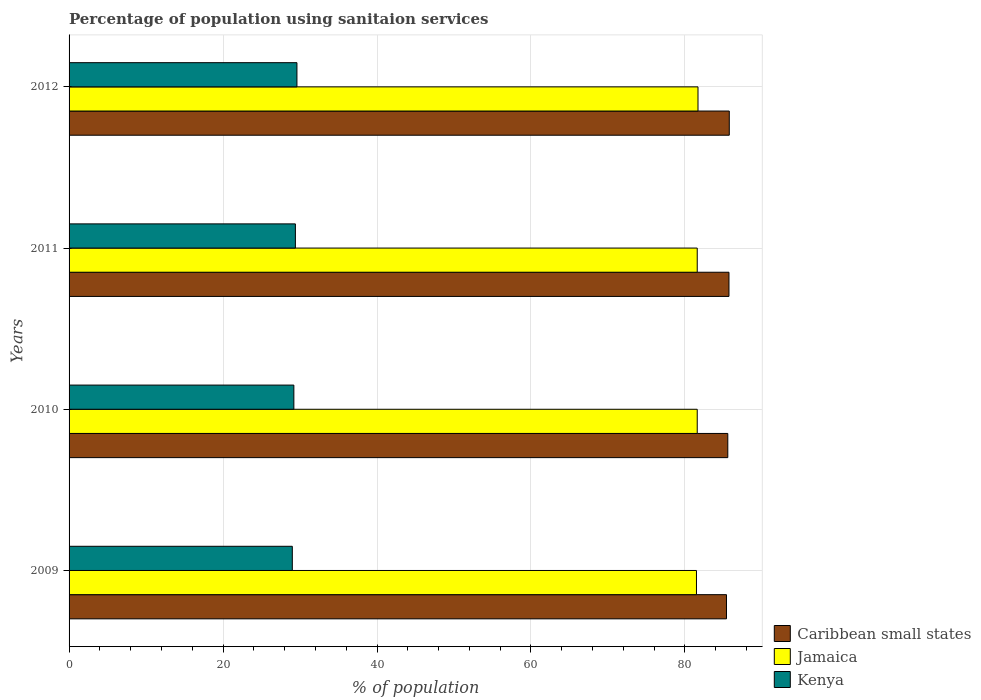How many different coloured bars are there?
Give a very brief answer. 3. Are the number of bars on each tick of the Y-axis equal?
Your answer should be compact. Yes. How many bars are there on the 3rd tick from the top?
Give a very brief answer. 3. What is the percentage of population using sanitaion services in Jamaica in 2009?
Offer a terse response. 81.5. Across all years, what is the maximum percentage of population using sanitaion services in Jamaica?
Your answer should be compact. 81.7. Across all years, what is the minimum percentage of population using sanitaion services in Jamaica?
Keep it short and to the point. 81.5. In which year was the percentage of population using sanitaion services in Caribbean small states maximum?
Your answer should be compact. 2012. In which year was the percentage of population using sanitaion services in Jamaica minimum?
Offer a terse response. 2009. What is the total percentage of population using sanitaion services in Kenya in the graph?
Give a very brief answer. 117.2. What is the difference between the percentage of population using sanitaion services in Kenya in 2009 and that in 2010?
Your response must be concise. -0.2. What is the difference between the percentage of population using sanitaion services in Caribbean small states in 2009 and the percentage of population using sanitaion services in Jamaica in 2012?
Offer a very short reply. 3.7. What is the average percentage of population using sanitaion services in Jamaica per year?
Provide a short and direct response. 81.6. In the year 2010, what is the difference between the percentage of population using sanitaion services in Caribbean small states and percentage of population using sanitaion services in Jamaica?
Provide a short and direct response. 3.97. What is the ratio of the percentage of population using sanitaion services in Jamaica in 2009 to that in 2010?
Your response must be concise. 1. Is the percentage of population using sanitaion services in Caribbean small states in 2009 less than that in 2011?
Ensure brevity in your answer.  Yes. Is the difference between the percentage of population using sanitaion services in Caribbean small states in 2009 and 2012 greater than the difference between the percentage of population using sanitaion services in Jamaica in 2009 and 2012?
Provide a short and direct response. No. What is the difference between the highest and the second highest percentage of population using sanitaion services in Jamaica?
Provide a short and direct response. 0.1. What is the difference between the highest and the lowest percentage of population using sanitaion services in Caribbean small states?
Make the answer very short. 0.36. Is the sum of the percentage of population using sanitaion services in Caribbean small states in 2009 and 2010 greater than the maximum percentage of population using sanitaion services in Jamaica across all years?
Your answer should be very brief. Yes. What does the 1st bar from the top in 2010 represents?
Your response must be concise. Kenya. What does the 2nd bar from the bottom in 2009 represents?
Provide a succinct answer. Jamaica. Is it the case that in every year, the sum of the percentage of population using sanitaion services in Caribbean small states and percentage of population using sanitaion services in Kenya is greater than the percentage of population using sanitaion services in Jamaica?
Your answer should be compact. Yes. Are all the bars in the graph horizontal?
Offer a very short reply. Yes. What is the difference between two consecutive major ticks on the X-axis?
Offer a very short reply. 20. Does the graph contain any zero values?
Keep it short and to the point. No. Where does the legend appear in the graph?
Your response must be concise. Bottom right. How many legend labels are there?
Keep it short and to the point. 3. How are the legend labels stacked?
Offer a terse response. Vertical. What is the title of the graph?
Provide a short and direct response. Percentage of population using sanitaion services. What is the label or title of the X-axis?
Provide a succinct answer. % of population. What is the % of population of Caribbean small states in 2009?
Offer a very short reply. 85.4. What is the % of population in Jamaica in 2009?
Offer a terse response. 81.5. What is the % of population of Kenya in 2009?
Provide a short and direct response. 29. What is the % of population in Caribbean small states in 2010?
Ensure brevity in your answer.  85.57. What is the % of population in Jamaica in 2010?
Keep it short and to the point. 81.6. What is the % of population of Kenya in 2010?
Provide a succinct answer. 29.2. What is the % of population of Caribbean small states in 2011?
Ensure brevity in your answer.  85.72. What is the % of population in Jamaica in 2011?
Provide a succinct answer. 81.6. What is the % of population of Kenya in 2011?
Make the answer very short. 29.4. What is the % of population in Caribbean small states in 2012?
Your answer should be very brief. 85.76. What is the % of population of Jamaica in 2012?
Your answer should be compact. 81.7. What is the % of population of Kenya in 2012?
Provide a succinct answer. 29.6. Across all years, what is the maximum % of population in Caribbean small states?
Give a very brief answer. 85.76. Across all years, what is the maximum % of population in Jamaica?
Offer a very short reply. 81.7. Across all years, what is the maximum % of population of Kenya?
Your response must be concise. 29.6. Across all years, what is the minimum % of population in Caribbean small states?
Provide a short and direct response. 85.4. Across all years, what is the minimum % of population of Jamaica?
Keep it short and to the point. 81.5. What is the total % of population of Caribbean small states in the graph?
Your response must be concise. 342.45. What is the total % of population in Jamaica in the graph?
Make the answer very short. 326.4. What is the total % of population of Kenya in the graph?
Give a very brief answer. 117.2. What is the difference between the % of population of Caribbean small states in 2009 and that in 2010?
Ensure brevity in your answer.  -0.17. What is the difference between the % of population of Kenya in 2009 and that in 2010?
Your answer should be compact. -0.2. What is the difference between the % of population in Caribbean small states in 2009 and that in 2011?
Your response must be concise. -0.32. What is the difference between the % of population of Jamaica in 2009 and that in 2011?
Give a very brief answer. -0.1. What is the difference between the % of population of Kenya in 2009 and that in 2011?
Offer a very short reply. -0.4. What is the difference between the % of population in Caribbean small states in 2009 and that in 2012?
Provide a succinct answer. -0.36. What is the difference between the % of population in Jamaica in 2009 and that in 2012?
Keep it short and to the point. -0.2. What is the difference between the % of population in Kenya in 2009 and that in 2012?
Offer a terse response. -0.6. What is the difference between the % of population in Caribbean small states in 2010 and that in 2011?
Keep it short and to the point. -0.15. What is the difference between the % of population of Caribbean small states in 2010 and that in 2012?
Your response must be concise. -0.19. What is the difference between the % of population in Kenya in 2010 and that in 2012?
Provide a succinct answer. -0.4. What is the difference between the % of population of Caribbean small states in 2011 and that in 2012?
Provide a short and direct response. -0.04. What is the difference between the % of population in Jamaica in 2011 and that in 2012?
Keep it short and to the point. -0.1. What is the difference between the % of population of Kenya in 2011 and that in 2012?
Give a very brief answer. -0.2. What is the difference between the % of population in Caribbean small states in 2009 and the % of population in Jamaica in 2010?
Your response must be concise. 3.8. What is the difference between the % of population in Caribbean small states in 2009 and the % of population in Kenya in 2010?
Your answer should be compact. 56.2. What is the difference between the % of population of Jamaica in 2009 and the % of population of Kenya in 2010?
Provide a short and direct response. 52.3. What is the difference between the % of population in Caribbean small states in 2009 and the % of population in Jamaica in 2011?
Give a very brief answer. 3.8. What is the difference between the % of population in Caribbean small states in 2009 and the % of population in Kenya in 2011?
Offer a terse response. 56. What is the difference between the % of population in Jamaica in 2009 and the % of population in Kenya in 2011?
Offer a very short reply. 52.1. What is the difference between the % of population of Caribbean small states in 2009 and the % of population of Jamaica in 2012?
Offer a very short reply. 3.7. What is the difference between the % of population of Caribbean small states in 2009 and the % of population of Kenya in 2012?
Give a very brief answer. 55.8. What is the difference between the % of population in Jamaica in 2009 and the % of population in Kenya in 2012?
Keep it short and to the point. 51.9. What is the difference between the % of population of Caribbean small states in 2010 and the % of population of Jamaica in 2011?
Provide a short and direct response. 3.97. What is the difference between the % of population in Caribbean small states in 2010 and the % of population in Kenya in 2011?
Your answer should be compact. 56.17. What is the difference between the % of population of Jamaica in 2010 and the % of population of Kenya in 2011?
Keep it short and to the point. 52.2. What is the difference between the % of population of Caribbean small states in 2010 and the % of population of Jamaica in 2012?
Your answer should be very brief. 3.87. What is the difference between the % of population in Caribbean small states in 2010 and the % of population in Kenya in 2012?
Provide a succinct answer. 55.97. What is the difference between the % of population of Jamaica in 2010 and the % of population of Kenya in 2012?
Your response must be concise. 52. What is the difference between the % of population of Caribbean small states in 2011 and the % of population of Jamaica in 2012?
Provide a succinct answer. 4.02. What is the difference between the % of population of Caribbean small states in 2011 and the % of population of Kenya in 2012?
Your response must be concise. 56.12. What is the difference between the % of population in Jamaica in 2011 and the % of population in Kenya in 2012?
Keep it short and to the point. 52. What is the average % of population of Caribbean small states per year?
Give a very brief answer. 85.61. What is the average % of population of Jamaica per year?
Provide a succinct answer. 81.6. What is the average % of population in Kenya per year?
Offer a terse response. 29.3. In the year 2009, what is the difference between the % of population of Caribbean small states and % of population of Jamaica?
Keep it short and to the point. 3.9. In the year 2009, what is the difference between the % of population of Caribbean small states and % of population of Kenya?
Offer a very short reply. 56.4. In the year 2009, what is the difference between the % of population in Jamaica and % of population in Kenya?
Your answer should be compact. 52.5. In the year 2010, what is the difference between the % of population in Caribbean small states and % of population in Jamaica?
Provide a short and direct response. 3.97. In the year 2010, what is the difference between the % of population of Caribbean small states and % of population of Kenya?
Offer a very short reply. 56.37. In the year 2010, what is the difference between the % of population in Jamaica and % of population in Kenya?
Your response must be concise. 52.4. In the year 2011, what is the difference between the % of population of Caribbean small states and % of population of Jamaica?
Give a very brief answer. 4.12. In the year 2011, what is the difference between the % of population of Caribbean small states and % of population of Kenya?
Ensure brevity in your answer.  56.32. In the year 2011, what is the difference between the % of population in Jamaica and % of population in Kenya?
Keep it short and to the point. 52.2. In the year 2012, what is the difference between the % of population of Caribbean small states and % of population of Jamaica?
Ensure brevity in your answer.  4.06. In the year 2012, what is the difference between the % of population of Caribbean small states and % of population of Kenya?
Your response must be concise. 56.16. In the year 2012, what is the difference between the % of population in Jamaica and % of population in Kenya?
Provide a succinct answer. 52.1. What is the ratio of the % of population in Caribbean small states in 2009 to that in 2010?
Your response must be concise. 1. What is the ratio of the % of population of Kenya in 2009 to that in 2011?
Ensure brevity in your answer.  0.99. What is the ratio of the % of population in Jamaica in 2009 to that in 2012?
Provide a short and direct response. 1. What is the ratio of the % of population of Kenya in 2009 to that in 2012?
Give a very brief answer. 0.98. What is the ratio of the % of population in Jamaica in 2010 to that in 2011?
Offer a very short reply. 1. What is the ratio of the % of population of Kenya in 2010 to that in 2011?
Offer a very short reply. 0.99. What is the ratio of the % of population in Caribbean small states in 2010 to that in 2012?
Provide a short and direct response. 1. What is the ratio of the % of population of Kenya in 2010 to that in 2012?
Your answer should be compact. 0.99. What is the ratio of the % of population of Jamaica in 2011 to that in 2012?
Provide a succinct answer. 1. What is the ratio of the % of population of Kenya in 2011 to that in 2012?
Ensure brevity in your answer.  0.99. What is the difference between the highest and the second highest % of population in Caribbean small states?
Provide a short and direct response. 0.04. What is the difference between the highest and the second highest % of population of Kenya?
Your answer should be compact. 0.2. What is the difference between the highest and the lowest % of population of Caribbean small states?
Provide a short and direct response. 0.36. What is the difference between the highest and the lowest % of population of Jamaica?
Make the answer very short. 0.2. 